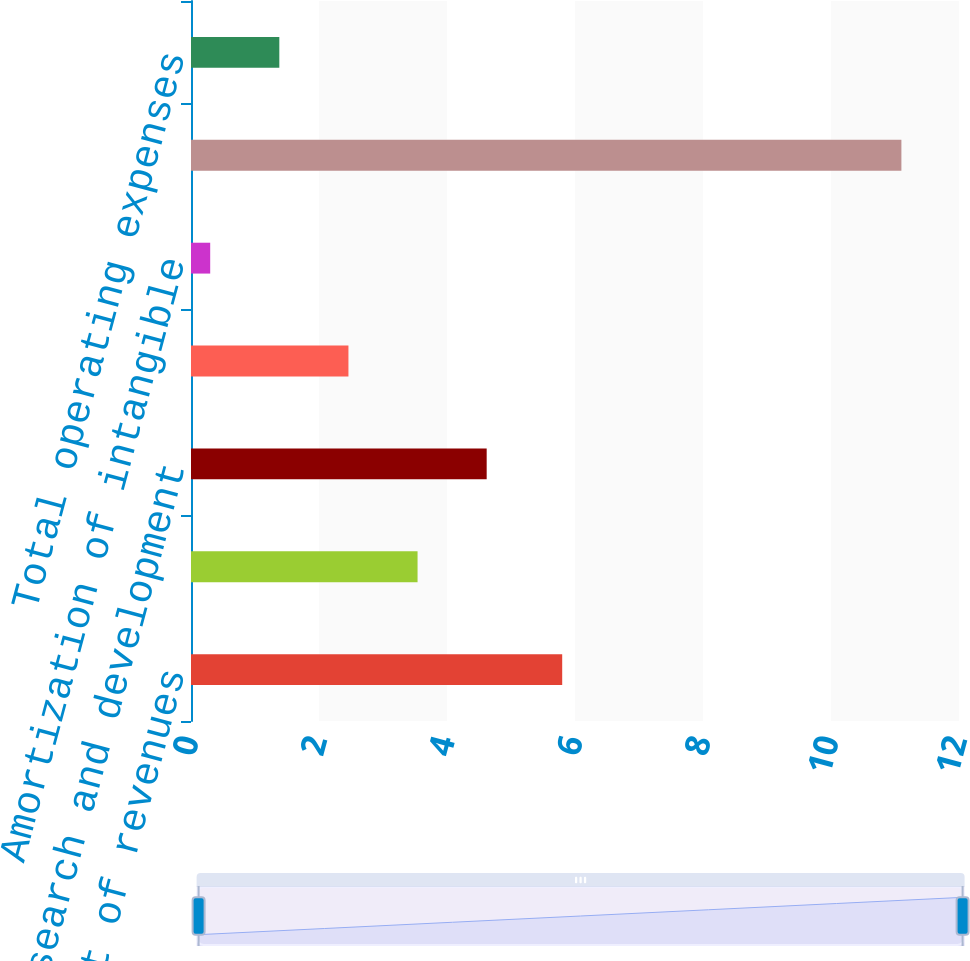Convert chart to OTSL. <chart><loc_0><loc_0><loc_500><loc_500><bar_chart><fcel>Cost of revenues<fcel>Selling and marketing<fcel>Research and development<fcel>General and administrative<fcel>Amortization of intangible<fcel>Depreciation and amortization<fcel>Total operating expenses<nl><fcel>5.8<fcel>3.54<fcel>4.62<fcel>2.46<fcel>0.3<fcel>11.1<fcel>1.38<nl></chart> 